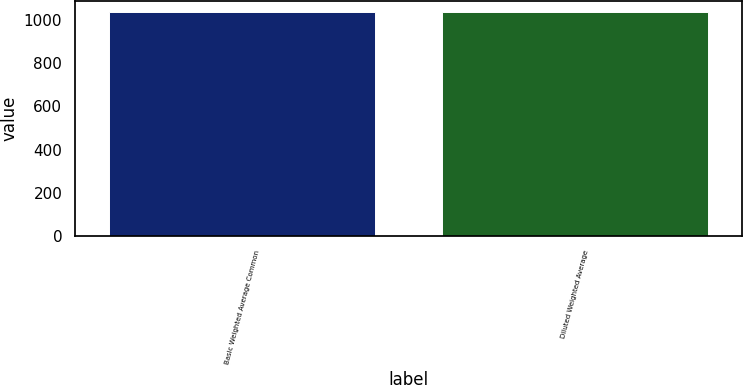<chart> <loc_0><loc_0><loc_500><loc_500><bar_chart><fcel>Basic Weighted Average Common<fcel>Diluted Weighted Average<nl><fcel>1036<fcel>1036.1<nl></chart> 